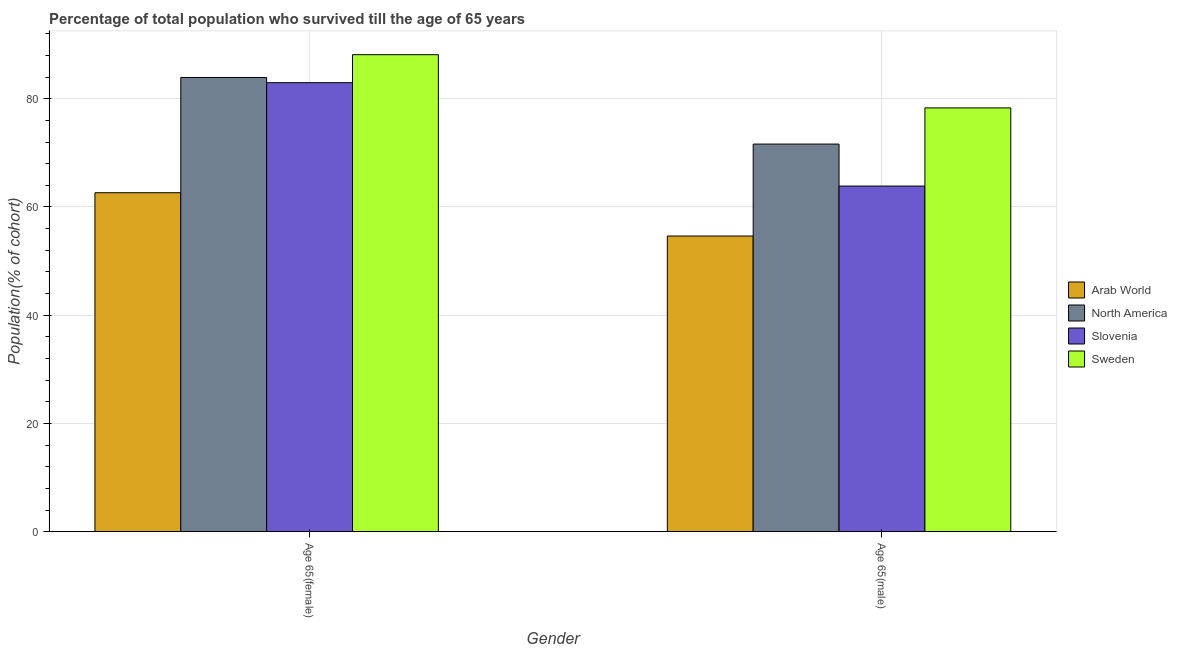How many groups of bars are there?
Give a very brief answer. 2. Are the number of bars per tick equal to the number of legend labels?
Offer a terse response. Yes. Are the number of bars on each tick of the X-axis equal?
Give a very brief answer. Yes. What is the label of the 1st group of bars from the left?
Make the answer very short. Age 65(female). What is the percentage of male population who survived till age of 65 in Slovenia?
Your response must be concise. 63.87. Across all countries, what is the maximum percentage of male population who survived till age of 65?
Keep it short and to the point. 78.31. Across all countries, what is the minimum percentage of female population who survived till age of 65?
Offer a very short reply. 62.63. In which country was the percentage of male population who survived till age of 65 minimum?
Ensure brevity in your answer.  Arab World. What is the total percentage of male population who survived till age of 65 in the graph?
Give a very brief answer. 268.43. What is the difference between the percentage of female population who survived till age of 65 in North America and that in Arab World?
Provide a succinct answer. 21.3. What is the difference between the percentage of female population who survived till age of 65 in Sweden and the percentage of male population who survived till age of 65 in Slovenia?
Keep it short and to the point. 24.27. What is the average percentage of male population who survived till age of 65 per country?
Keep it short and to the point. 67.11. What is the difference between the percentage of male population who survived till age of 65 and percentage of female population who survived till age of 65 in Slovenia?
Provide a short and direct response. -19.1. What is the ratio of the percentage of female population who survived till age of 65 in Arab World to that in Slovenia?
Offer a terse response. 0.75. Is the percentage of male population who survived till age of 65 in Arab World less than that in North America?
Provide a succinct answer. Yes. In how many countries, is the percentage of male population who survived till age of 65 greater than the average percentage of male population who survived till age of 65 taken over all countries?
Offer a terse response. 2. What does the 3rd bar from the left in Age 65(female) represents?
Keep it short and to the point. Slovenia. What does the 4th bar from the right in Age 65(male) represents?
Your answer should be compact. Arab World. How many countries are there in the graph?
Ensure brevity in your answer.  4. Does the graph contain grids?
Make the answer very short. Yes. How are the legend labels stacked?
Your answer should be very brief. Vertical. What is the title of the graph?
Your response must be concise. Percentage of total population who survived till the age of 65 years. Does "United Arab Emirates" appear as one of the legend labels in the graph?
Offer a very short reply. No. What is the label or title of the X-axis?
Your response must be concise. Gender. What is the label or title of the Y-axis?
Give a very brief answer. Population(% of cohort). What is the Population(% of cohort) in Arab World in Age 65(female)?
Offer a very short reply. 62.63. What is the Population(% of cohort) in North America in Age 65(female)?
Offer a very short reply. 83.93. What is the Population(% of cohort) in Slovenia in Age 65(female)?
Provide a succinct answer. 82.97. What is the Population(% of cohort) in Sweden in Age 65(female)?
Offer a very short reply. 88.14. What is the Population(% of cohort) in Arab World in Age 65(male)?
Provide a short and direct response. 54.63. What is the Population(% of cohort) of North America in Age 65(male)?
Keep it short and to the point. 71.62. What is the Population(% of cohort) of Slovenia in Age 65(male)?
Provide a short and direct response. 63.87. What is the Population(% of cohort) of Sweden in Age 65(male)?
Give a very brief answer. 78.31. Across all Gender, what is the maximum Population(% of cohort) of Arab World?
Offer a terse response. 62.63. Across all Gender, what is the maximum Population(% of cohort) in North America?
Your response must be concise. 83.93. Across all Gender, what is the maximum Population(% of cohort) in Slovenia?
Your response must be concise. 82.97. Across all Gender, what is the maximum Population(% of cohort) of Sweden?
Your answer should be compact. 88.14. Across all Gender, what is the minimum Population(% of cohort) in Arab World?
Your response must be concise. 54.63. Across all Gender, what is the minimum Population(% of cohort) in North America?
Make the answer very short. 71.62. Across all Gender, what is the minimum Population(% of cohort) of Slovenia?
Provide a short and direct response. 63.87. Across all Gender, what is the minimum Population(% of cohort) in Sweden?
Your response must be concise. 78.31. What is the total Population(% of cohort) in Arab World in the graph?
Your response must be concise. 117.26. What is the total Population(% of cohort) in North America in the graph?
Provide a short and direct response. 155.55. What is the total Population(% of cohort) of Slovenia in the graph?
Ensure brevity in your answer.  146.83. What is the total Population(% of cohort) in Sweden in the graph?
Give a very brief answer. 166.45. What is the difference between the Population(% of cohort) of Arab World in Age 65(female) and that in Age 65(male)?
Your response must be concise. 8. What is the difference between the Population(% of cohort) of North America in Age 65(female) and that in Age 65(male)?
Ensure brevity in your answer.  12.3. What is the difference between the Population(% of cohort) of Slovenia in Age 65(female) and that in Age 65(male)?
Your response must be concise. 19.1. What is the difference between the Population(% of cohort) in Sweden in Age 65(female) and that in Age 65(male)?
Provide a short and direct response. 9.83. What is the difference between the Population(% of cohort) of Arab World in Age 65(female) and the Population(% of cohort) of North America in Age 65(male)?
Make the answer very short. -8.99. What is the difference between the Population(% of cohort) in Arab World in Age 65(female) and the Population(% of cohort) in Slovenia in Age 65(male)?
Give a very brief answer. -1.24. What is the difference between the Population(% of cohort) of Arab World in Age 65(female) and the Population(% of cohort) of Sweden in Age 65(male)?
Offer a terse response. -15.68. What is the difference between the Population(% of cohort) in North America in Age 65(female) and the Population(% of cohort) in Slovenia in Age 65(male)?
Provide a succinct answer. 20.06. What is the difference between the Population(% of cohort) of North America in Age 65(female) and the Population(% of cohort) of Sweden in Age 65(male)?
Your response must be concise. 5.62. What is the difference between the Population(% of cohort) of Slovenia in Age 65(female) and the Population(% of cohort) of Sweden in Age 65(male)?
Your response must be concise. 4.66. What is the average Population(% of cohort) in Arab World per Gender?
Make the answer very short. 58.63. What is the average Population(% of cohort) in North America per Gender?
Provide a succinct answer. 77.78. What is the average Population(% of cohort) in Slovenia per Gender?
Ensure brevity in your answer.  73.42. What is the average Population(% of cohort) in Sweden per Gender?
Give a very brief answer. 83.22. What is the difference between the Population(% of cohort) of Arab World and Population(% of cohort) of North America in Age 65(female)?
Ensure brevity in your answer.  -21.3. What is the difference between the Population(% of cohort) in Arab World and Population(% of cohort) in Slovenia in Age 65(female)?
Offer a very short reply. -20.34. What is the difference between the Population(% of cohort) of Arab World and Population(% of cohort) of Sweden in Age 65(female)?
Your response must be concise. -25.51. What is the difference between the Population(% of cohort) of North America and Population(% of cohort) of Slovenia in Age 65(female)?
Provide a succinct answer. 0.96. What is the difference between the Population(% of cohort) in North America and Population(% of cohort) in Sweden in Age 65(female)?
Provide a short and direct response. -4.21. What is the difference between the Population(% of cohort) of Slovenia and Population(% of cohort) of Sweden in Age 65(female)?
Ensure brevity in your answer.  -5.17. What is the difference between the Population(% of cohort) of Arab World and Population(% of cohort) of North America in Age 65(male)?
Give a very brief answer. -16.99. What is the difference between the Population(% of cohort) of Arab World and Population(% of cohort) of Slovenia in Age 65(male)?
Ensure brevity in your answer.  -9.23. What is the difference between the Population(% of cohort) of Arab World and Population(% of cohort) of Sweden in Age 65(male)?
Ensure brevity in your answer.  -23.67. What is the difference between the Population(% of cohort) in North America and Population(% of cohort) in Slovenia in Age 65(male)?
Your answer should be compact. 7.76. What is the difference between the Population(% of cohort) in North America and Population(% of cohort) in Sweden in Age 65(male)?
Provide a short and direct response. -6.68. What is the difference between the Population(% of cohort) of Slovenia and Population(% of cohort) of Sweden in Age 65(male)?
Offer a terse response. -14.44. What is the ratio of the Population(% of cohort) in Arab World in Age 65(female) to that in Age 65(male)?
Provide a short and direct response. 1.15. What is the ratio of the Population(% of cohort) of North America in Age 65(female) to that in Age 65(male)?
Provide a short and direct response. 1.17. What is the ratio of the Population(% of cohort) in Slovenia in Age 65(female) to that in Age 65(male)?
Provide a short and direct response. 1.3. What is the ratio of the Population(% of cohort) in Sweden in Age 65(female) to that in Age 65(male)?
Your answer should be very brief. 1.13. What is the difference between the highest and the second highest Population(% of cohort) in Arab World?
Offer a very short reply. 8. What is the difference between the highest and the second highest Population(% of cohort) in North America?
Provide a succinct answer. 12.3. What is the difference between the highest and the second highest Population(% of cohort) in Slovenia?
Ensure brevity in your answer.  19.1. What is the difference between the highest and the second highest Population(% of cohort) of Sweden?
Ensure brevity in your answer.  9.83. What is the difference between the highest and the lowest Population(% of cohort) in Arab World?
Make the answer very short. 8. What is the difference between the highest and the lowest Population(% of cohort) of North America?
Keep it short and to the point. 12.3. What is the difference between the highest and the lowest Population(% of cohort) of Slovenia?
Your answer should be very brief. 19.1. What is the difference between the highest and the lowest Population(% of cohort) of Sweden?
Offer a terse response. 9.83. 